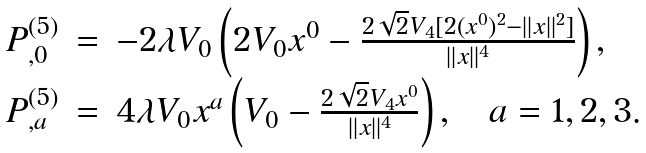Convert formula to latex. <formula><loc_0><loc_0><loc_500><loc_500>\begin{array} { r c l } P ^ { ( 5 ) } _ { , 0 } & = & - 2 \lambda V _ { 0 } \left ( 2 V _ { 0 } x ^ { 0 } - \frac { 2 \sqrt { 2 } V _ { 4 } [ 2 ( x ^ { 0 } ) ^ { 2 } - | | x | | ^ { 2 } ] } { | | x | | ^ { 4 } } \right ) , \\ P ^ { ( 5 ) } _ { , a } & = & 4 \lambda V _ { 0 } x ^ { a } \left ( V _ { 0 } - \frac { 2 \sqrt { 2 } V _ { 4 } x ^ { 0 } } { | | x | | ^ { 4 } } \right ) , \quad a = 1 , 2 , 3 . \end{array}</formula> 